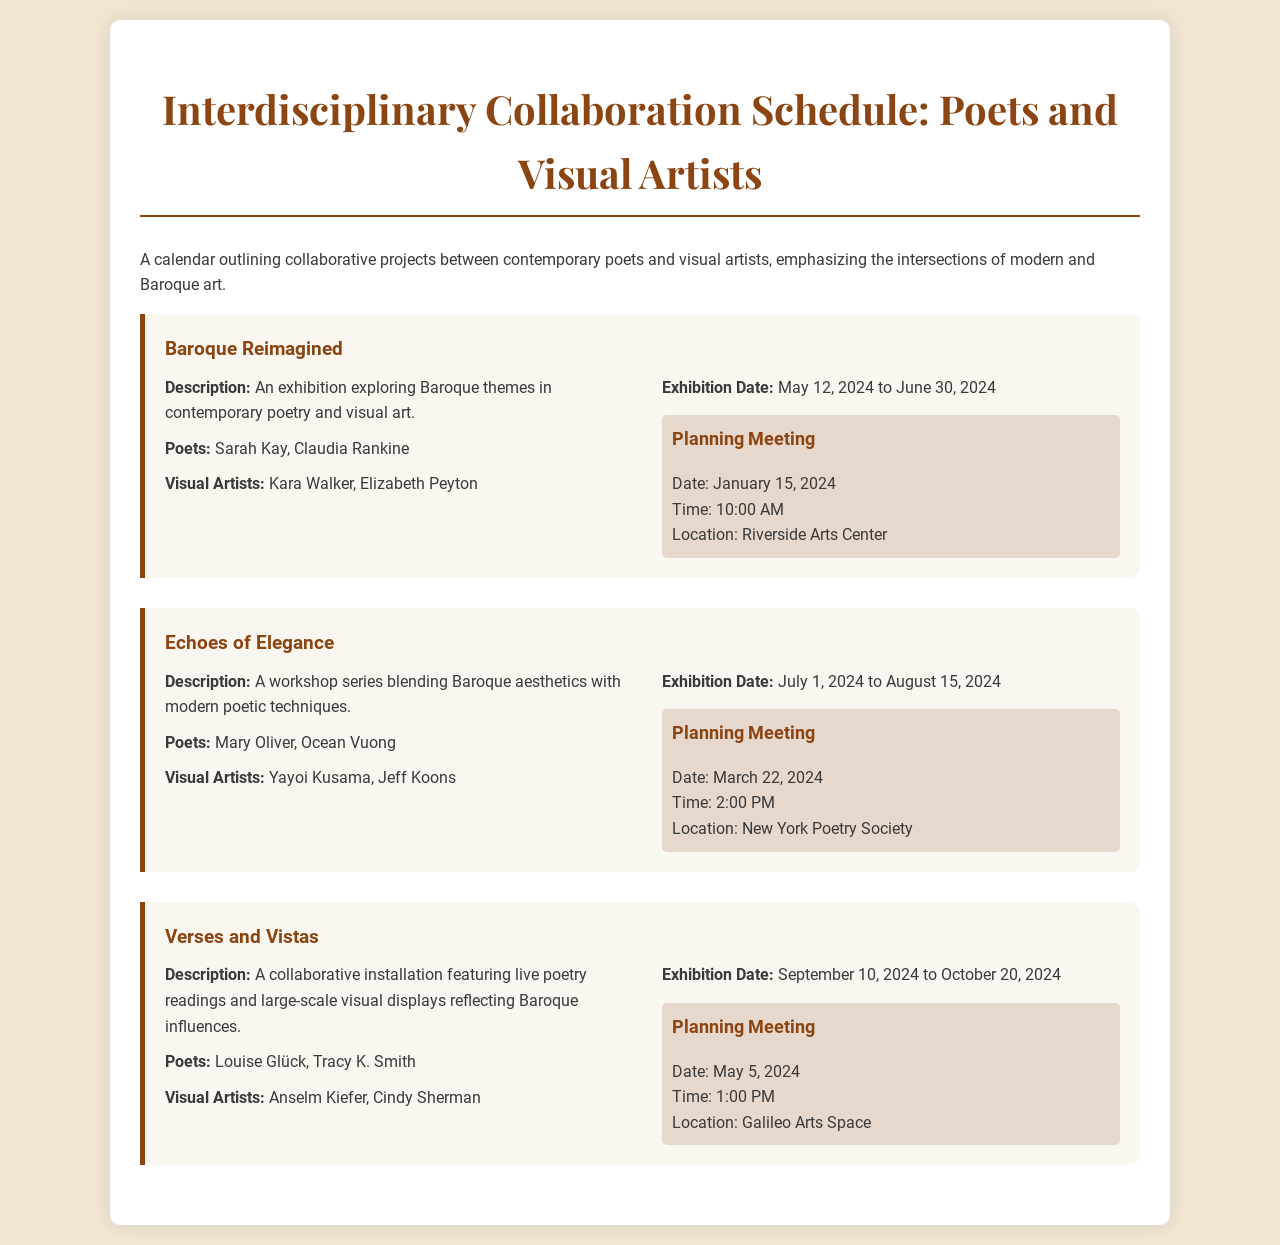What is the title of the first project? The title of the first project is listed in the document under "project-name."
Answer: Baroque Reimagined Who are the poets involved in the "Echoes of Elegance" project? The names of the poets are specified in the project details.
Answer: Mary Oliver, Ocean Vuong What is the exhibition date for "Verses and Vistas"? The exhibition date is given in the project details section.
Answer: September 10, 2024 to October 20, 2024 When is the planning meeting for "Baroque Reimagined"? The date of the planning meeting is provided in the meeting info within the project.
Answer: January 15, 2024 Which visual artist is collaborating with Sarah Kay in the first project? The collaborating visual artists are listed next to the corresponding poets in the project details.
Answer: Kara Walker What is the common theme explored across all projects? The theme can be inferred from the project descriptions and titles.
Answer: Baroque How many planning meetings are scheduled across all projects? The number of planning meetings can be counted from the meeting information provided in each project.
Answer: 3 What is the location of the planning meeting for "Echoes of Elegance"? The location is specified in the meeting information section of the project.
Answer: New York Poetry Society What type of collaborative installation is featured in "Verses and Vistas"? The type of installation is described in the project overview.
Answer: Live poetry readings and large-scale visual displays 